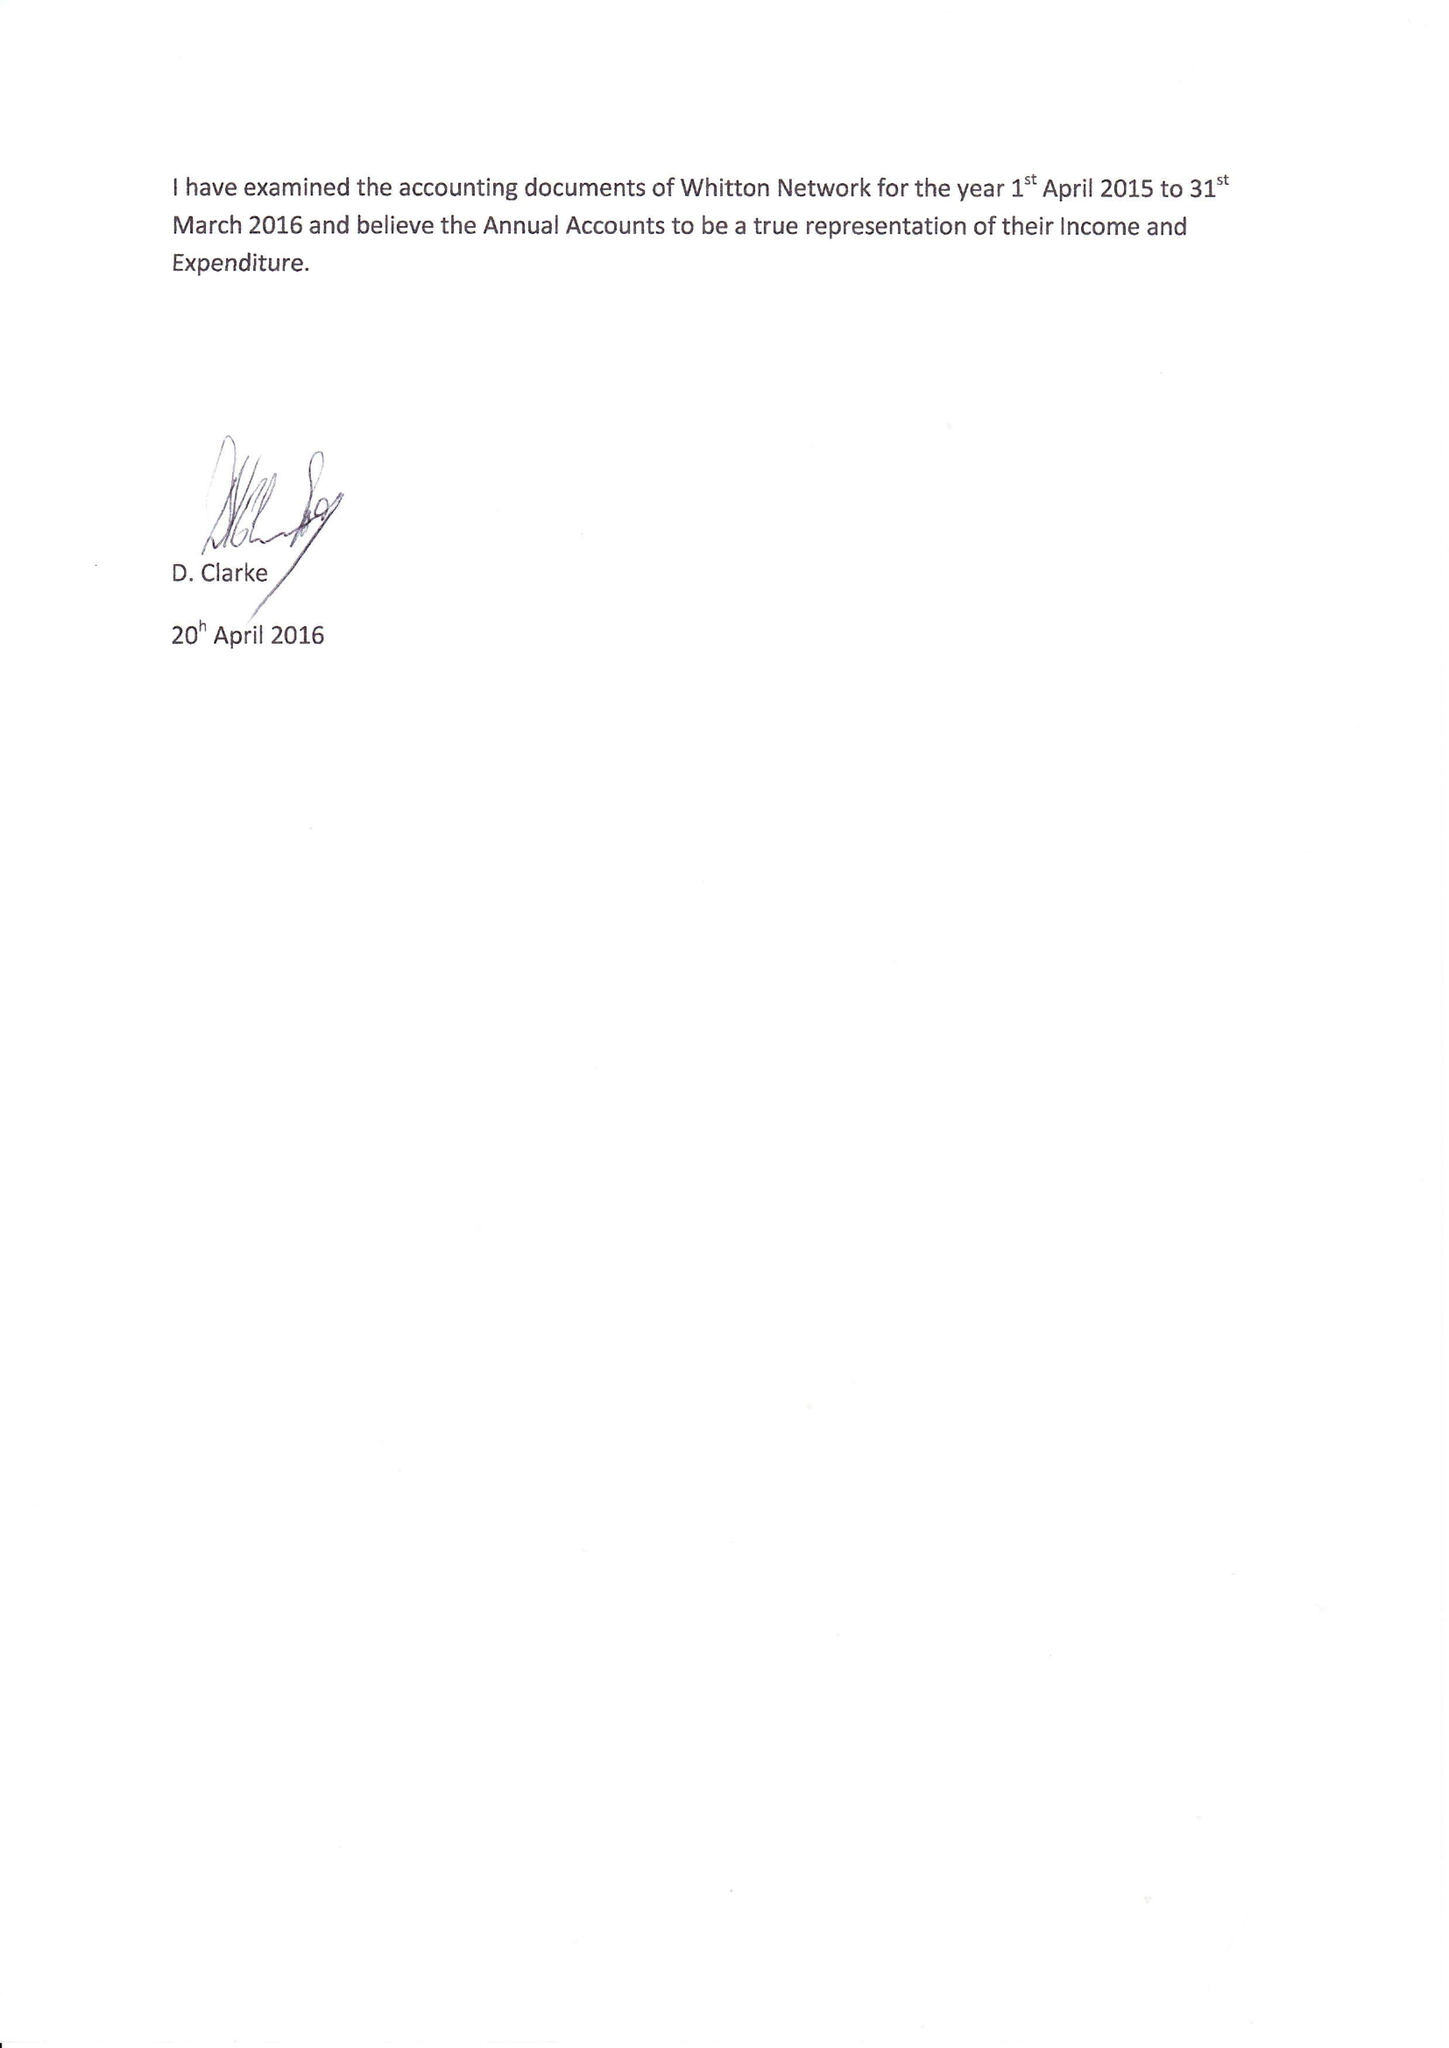What is the value for the spending_annually_in_british_pounds?
Answer the question using a single word or phrase. 47959.00 